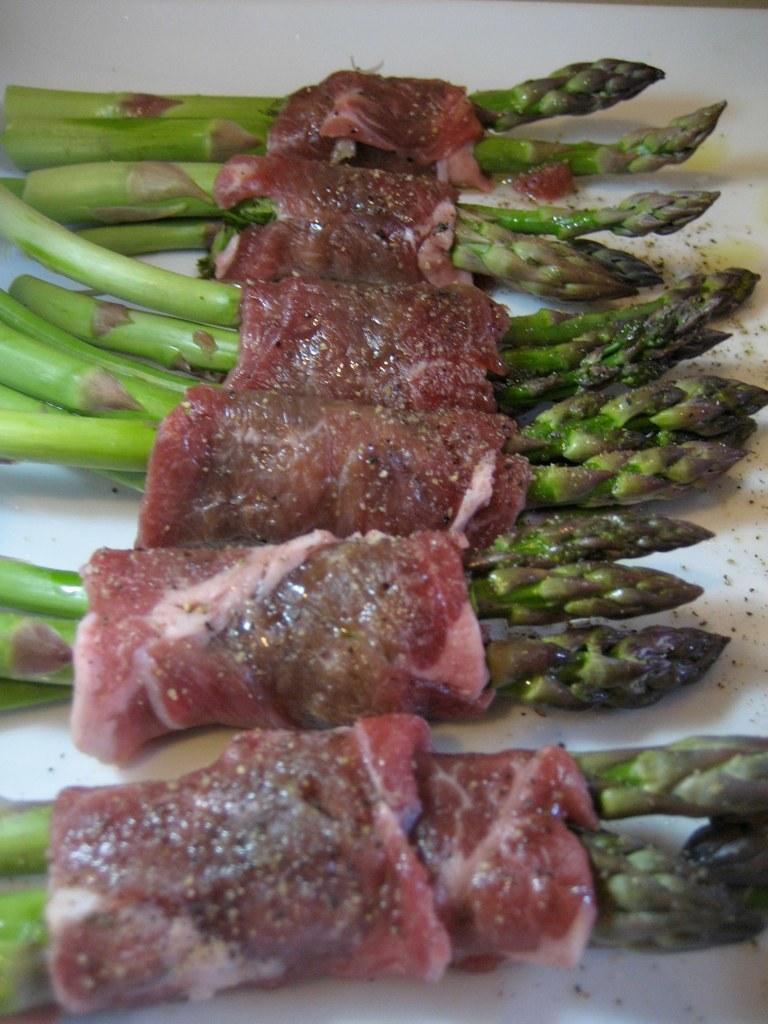Describe this image in one or two sentences. In the center of the image we can see food placed on the table. 